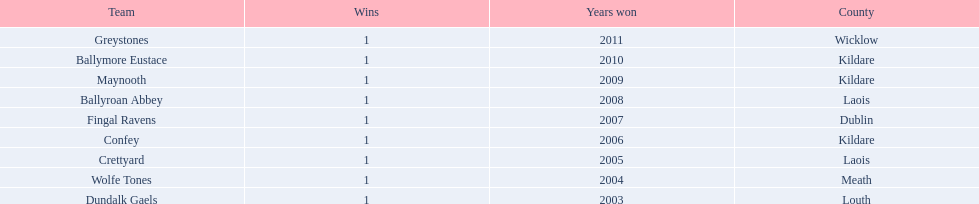Could you help me parse every detail presented in this table? {'header': ['Team', 'Wins', 'Years won', 'County'], 'rows': [['Greystones', '1', '2011', 'Wicklow'], ['Ballymore Eustace', '1', '2010', 'Kildare'], ['Maynooth', '1', '2009', 'Kildare'], ['Ballyroan Abbey', '1', '2008', 'Laois'], ['Fingal Ravens', '1', '2007', 'Dublin'], ['Confey', '1', '2006', 'Kildare'], ['Crettyard', '1', '2005', 'Laois'], ['Wolfe Tones', '1', '2004', 'Meath'], ['Dundalk Gaels', '1', '2003', 'Louth']]} What county is ballymore eustace from? Kildare. Besides convey, which other team is from the same county? Maynooth. 